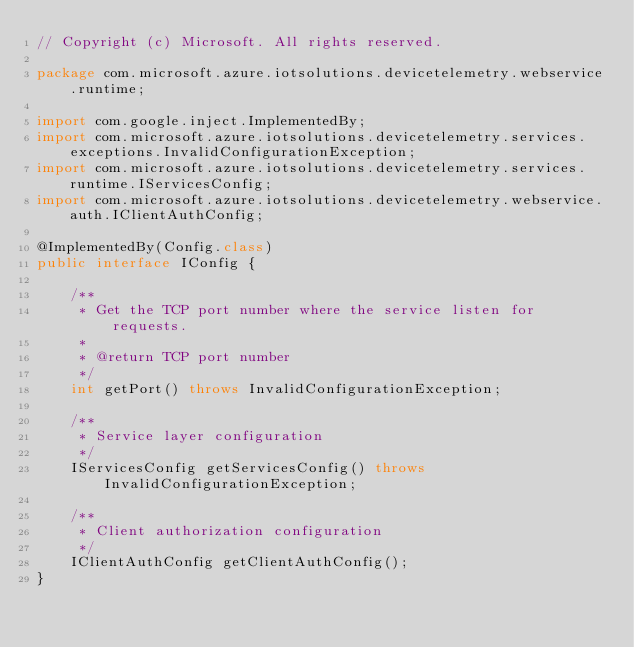Convert code to text. <code><loc_0><loc_0><loc_500><loc_500><_Java_>// Copyright (c) Microsoft. All rights reserved.

package com.microsoft.azure.iotsolutions.devicetelemetry.webservice.runtime;

import com.google.inject.ImplementedBy;
import com.microsoft.azure.iotsolutions.devicetelemetry.services.exceptions.InvalidConfigurationException;
import com.microsoft.azure.iotsolutions.devicetelemetry.services.runtime.IServicesConfig;
import com.microsoft.azure.iotsolutions.devicetelemetry.webservice.auth.IClientAuthConfig;

@ImplementedBy(Config.class)
public interface IConfig {

    /**
     * Get the TCP port number where the service listen for requests.
     *
     * @return TCP port number
     */
    int getPort() throws InvalidConfigurationException;

    /**
     * Service layer configuration
     */
    IServicesConfig getServicesConfig() throws InvalidConfigurationException;

    /**
     * Client authorization configuration
     */
    IClientAuthConfig getClientAuthConfig();
}
</code> 